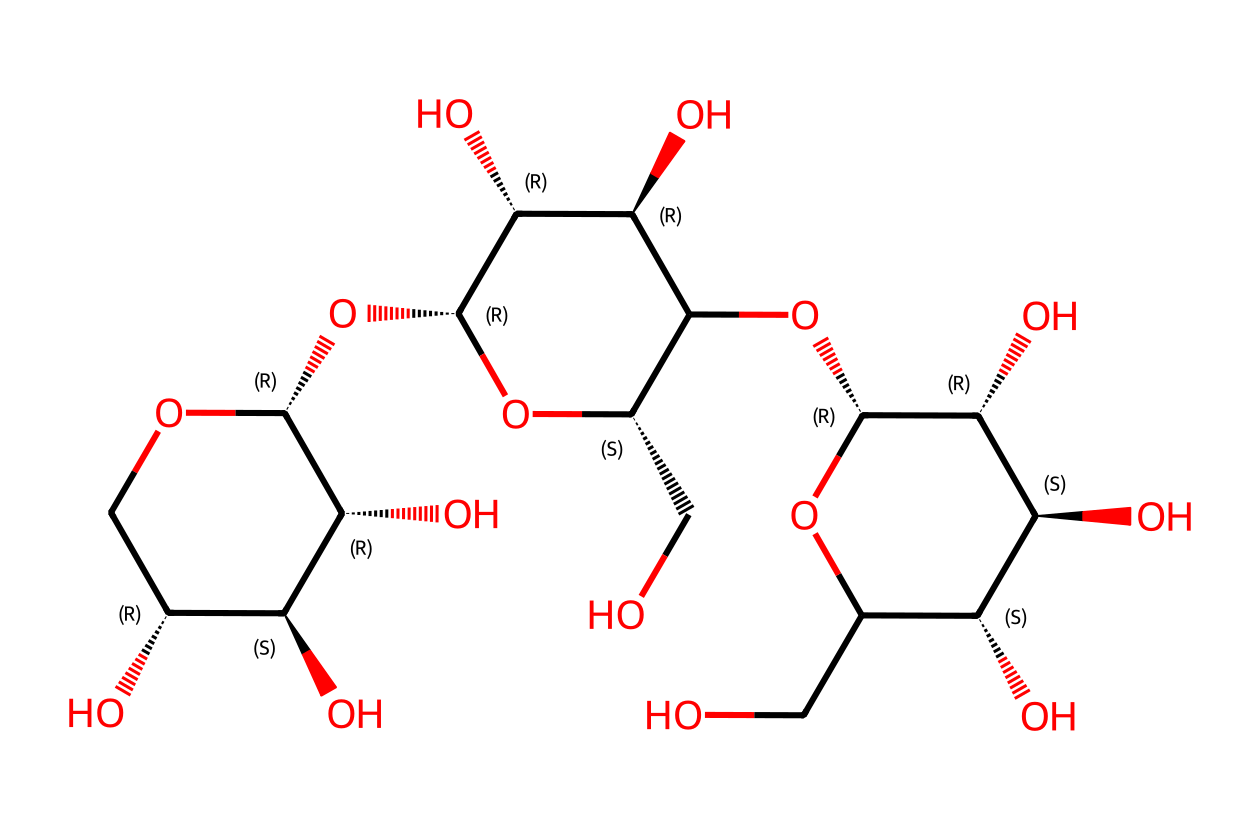What is the main type of polymer represented in this structure? The chemical structure represents cellulose, which is a natural polymer made of glucose units linked by β(1→4) glycosidic bonds. This can be identified from its repeating units of glucose and the hydroxy (–OH) groups present throughout.
Answer: cellulose How many rings are present in this chemical structure? By examining the structure, I see two distinct ring structures (the two "C1O" and "C2O" sections), indicating a bicyclic formation typical in polysaccharides like cellulose.
Answer: 2 What functional groups are found in this cellulose structure? The structure contains multiple hydroxyl (-OH) groups, which are indicative of its hydrophilic nature and contribute to the physical properties of cellulose, particularly its solubility and reactivity.
Answer: hydroxyl groups How many oxygen atoms are present in this molecule? By counting each oxygen atom directly in the structure, I identify a total of 6 oxygen atoms, which are critical for the molecular connectivity in cellulose.
Answer: 6 What is the primary building block unit of this polymer? The primary building block unit observed in this structure is glucose, as indicated by the repeating sugar ring formations characteristic of cellulose.
Answer: glucose What type of glycosidic bond is present in cellulose? The chemical structure indicates that cellulose has β(1→4) glycosidic bonds, which connect the glucose units and is crucial for its structural integrity.
Answer: β(1→4) glycosidic bonds 